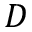Convert formula to latex. <formula><loc_0><loc_0><loc_500><loc_500>D</formula> 